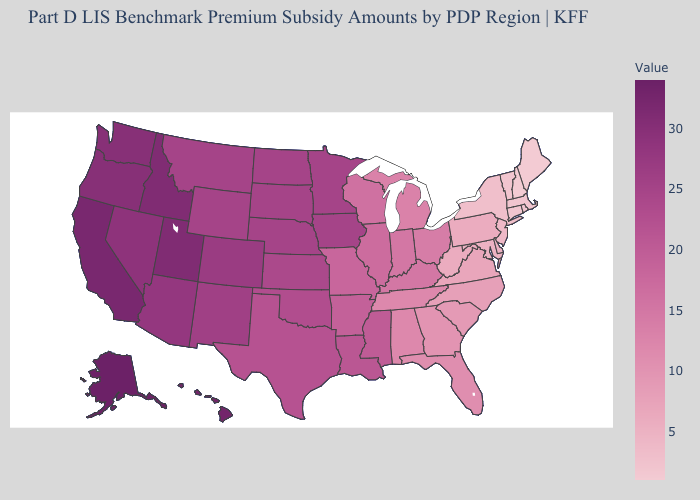Does Louisiana have a higher value than Massachusetts?
Short answer required. Yes. Does Illinois have a lower value than Montana?
Keep it brief. Yes. Does Nebraska have a higher value than Connecticut?
Short answer required. Yes. Does New Jersey have the highest value in the USA?
Write a very short answer. No. 